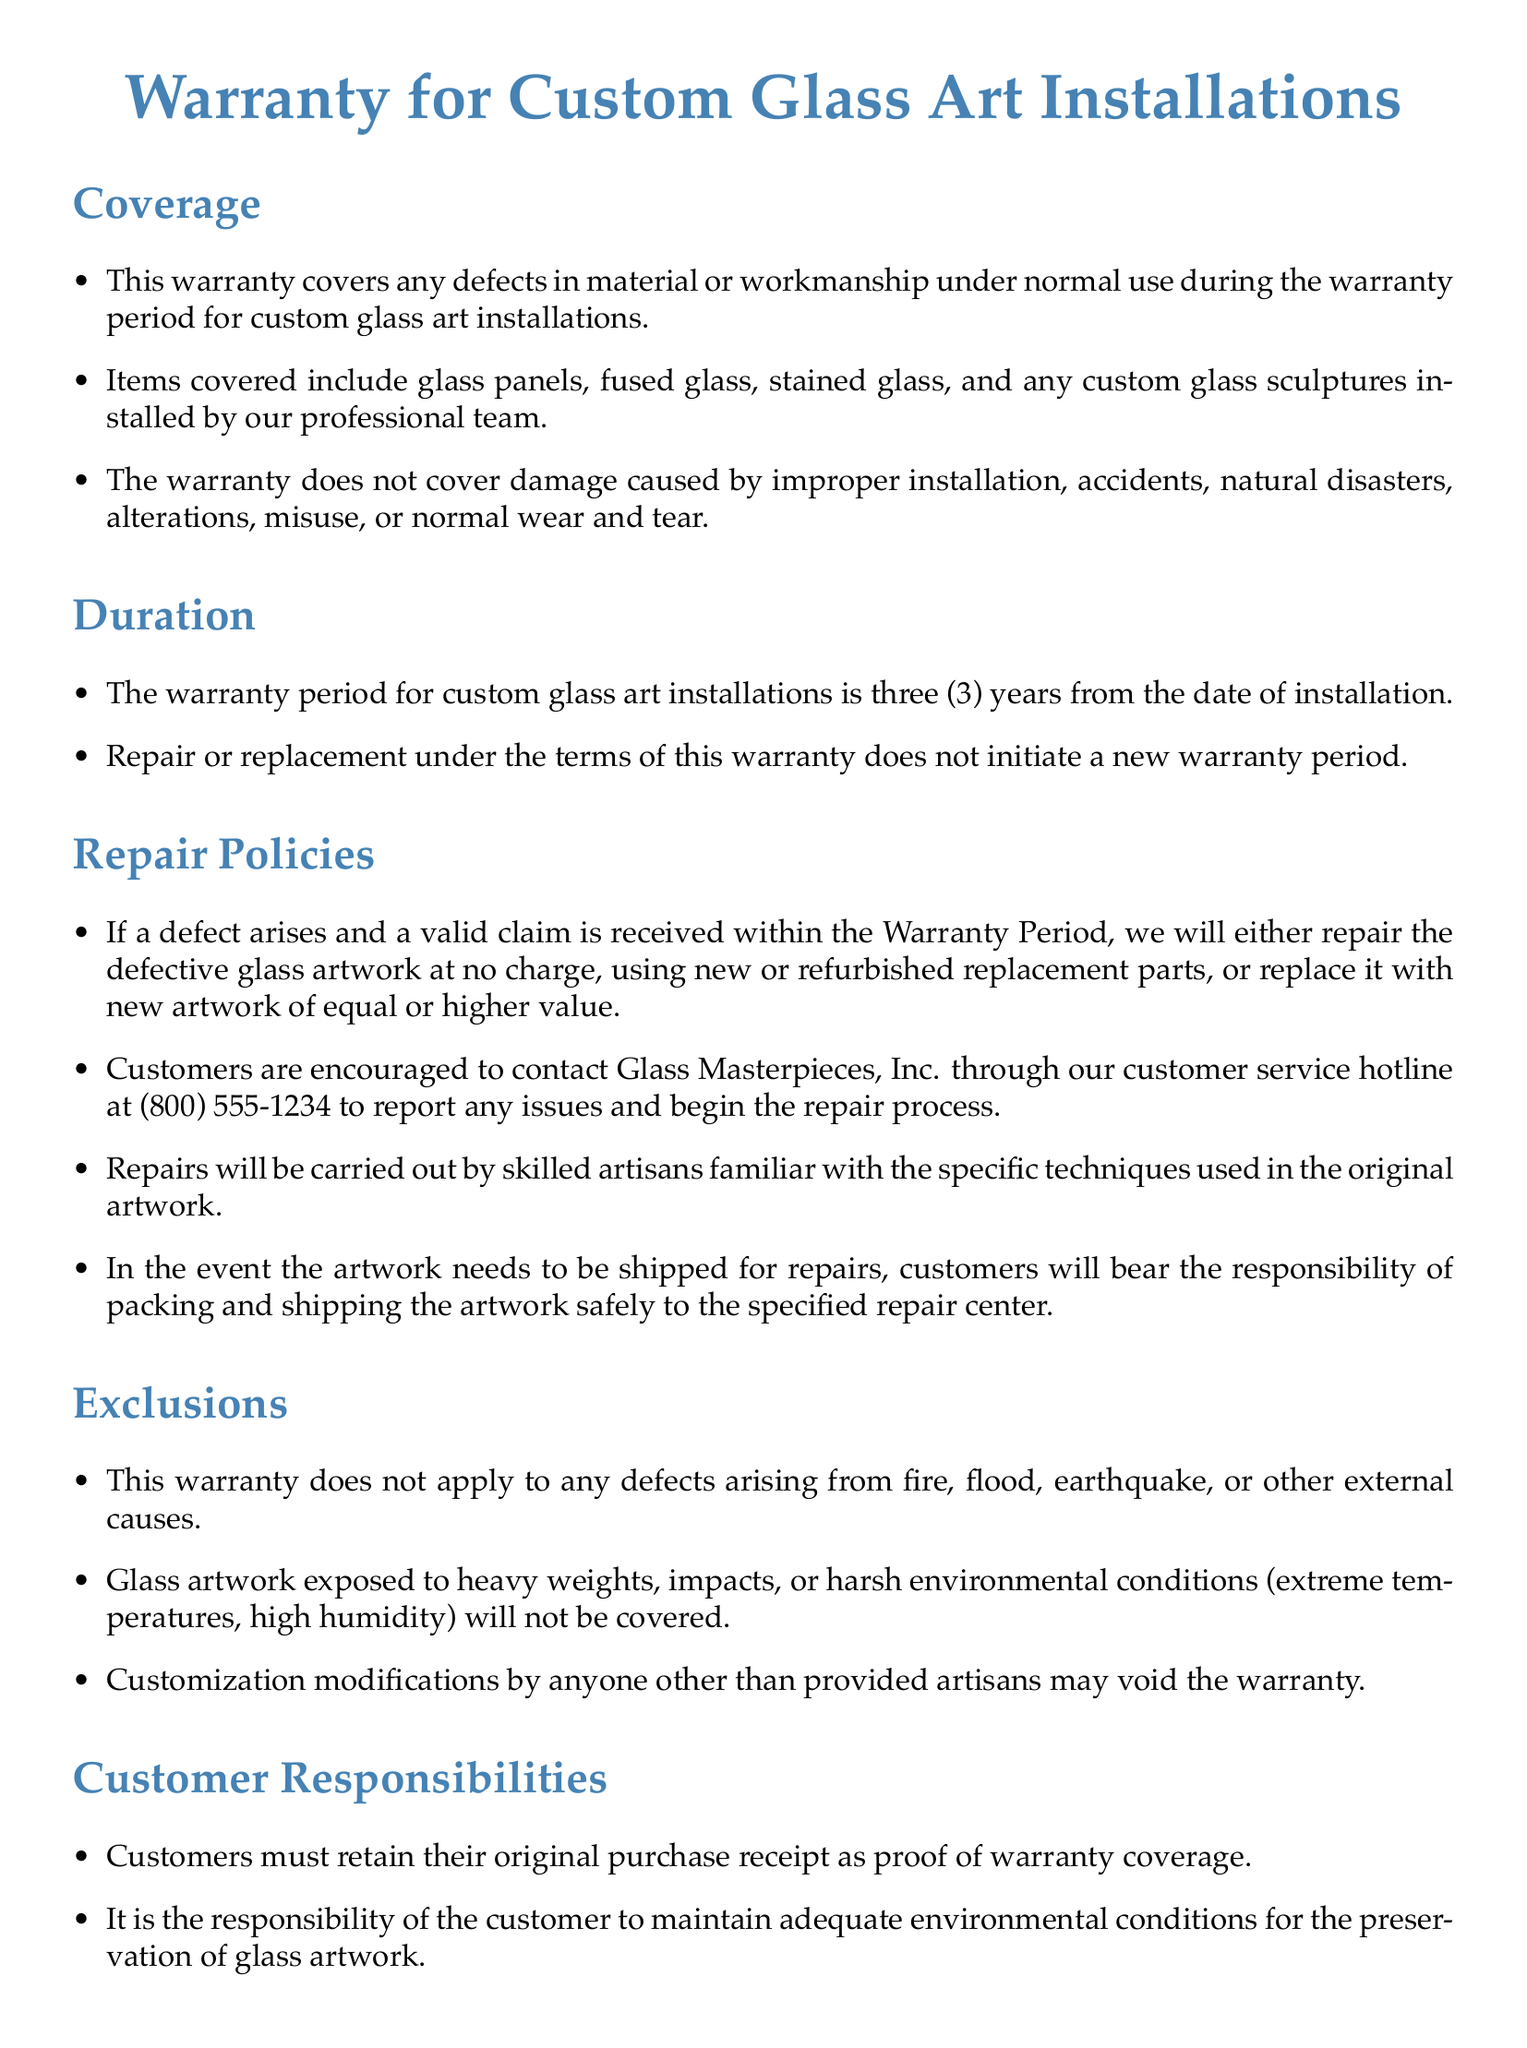What does the warranty cover? The warranty covers defects in material or workmanship under normal use for custom glass art installations.
Answer: defects in material or workmanship What is the duration of the warranty? The duration of the warranty is specified in the document, which states it lasts for a particular number of years after installation.
Answer: three (3) years What should customers retain as proof of warranty coverage? The document specifies that customers must keep a specific document for warranty proof, indicating its importance.
Answer: original purchase receipt What is excluded from the warranty coverage? The document lists conditions under which the warranty does not apply, summarizing specific situations.
Answer: fire, flood, earthquake How will the repairs be carried out? The document describes who will perform repairs and their qualifications, indicating a role of expertise in the process.
Answer: skilled artisans What should customers do if they need repairs? The warranty outlines the initial step customers are encouraged to take when they have an issue with their glass artwork.
Answer: contact customer service hotline What responsibility do customers have regarding environmental conditions? The document mentions a specific requirement for customers related to the maintenance of their glass artwork.
Answer: maintain adequate environmental conditions What happens to the warranty if the artwork is modified? The document indicates consequences for unauthorized actions regarding the artwork that can affect warranty validity.
Answer: void the warranty What type of artwork is covered under the warranty? The document specifies types of installations that are included under warranty coverage, mentioning categories of artwork.
Answer: glass panels, fused glass, stained glass, custom glass sculptures 